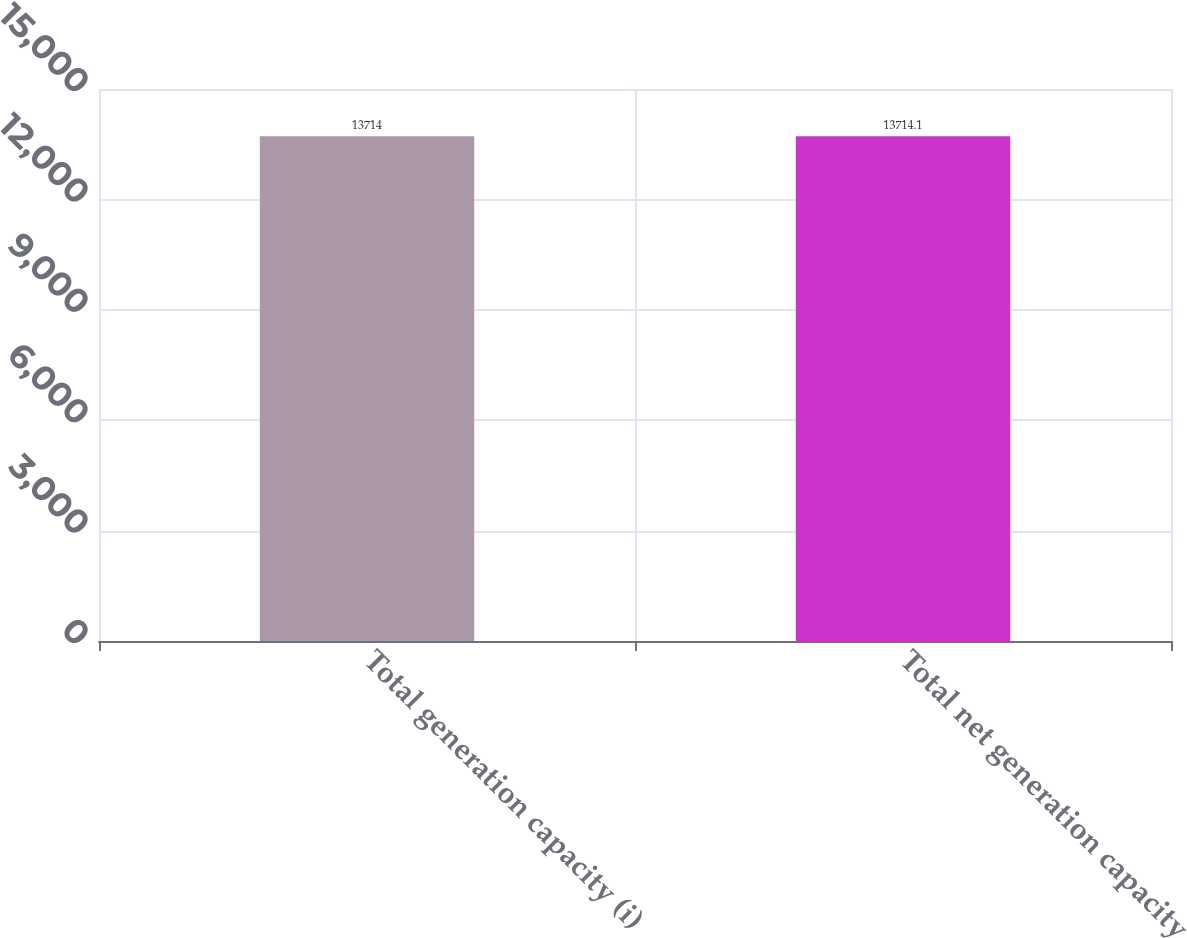<chart> <loc_0><loc_0><loc_500><loc_500><bar_chart><fcel>Total generation capacity (i)<fcel>Total net generation capacity<nl><fcel>13714<fcel>13714.1<nl></chart> 